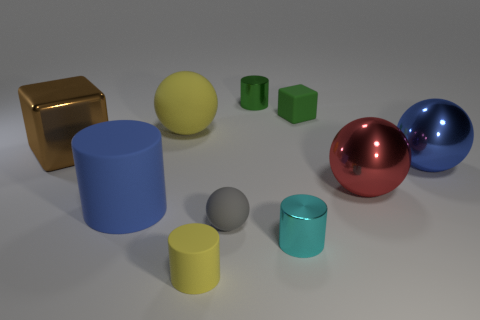What number of things are both in front of the small matte cube and on the left side of the cyan object?
Keep it short and to the point. 5. There is a green shiny thing; is it the same size as the cube that is right of the small cyan object?
Your answer should be compact. Yes. There is a green thing that is right of the cylinder that is behind the blue thing on the left side of the red ball; what is its size?
Give a very brief answer. Small. How big is the yellow matte thing that is in front of the gray ball?
Make the answer very short. Small. There is a big blue thing that is the same material as the yellow cylinder; what is its shape?
Your response must be concise. Cylinder. Is the tiny cylinder on the right side of the tiny green cylinder made of the same material as the brown block?
Offer a terse response. Yes. How many other objects are the same material as the tiny cyan cylinder?
Your response must be concise. 4. How many things are large metallic objects that are on the right side of the big brown thing or rubber objects in front of the big metal cube?
Give a very brief answer. 5. There is a yellow matte object in front of the blue rubber object; is its shape the same as the yellow object that is behind the small yellow matte cylinder?
Offer a very short reply. No. There is a gray thing that is the same size as the cyan metallic object; what is its shape?
Keep it short and to the point. Sphere. 